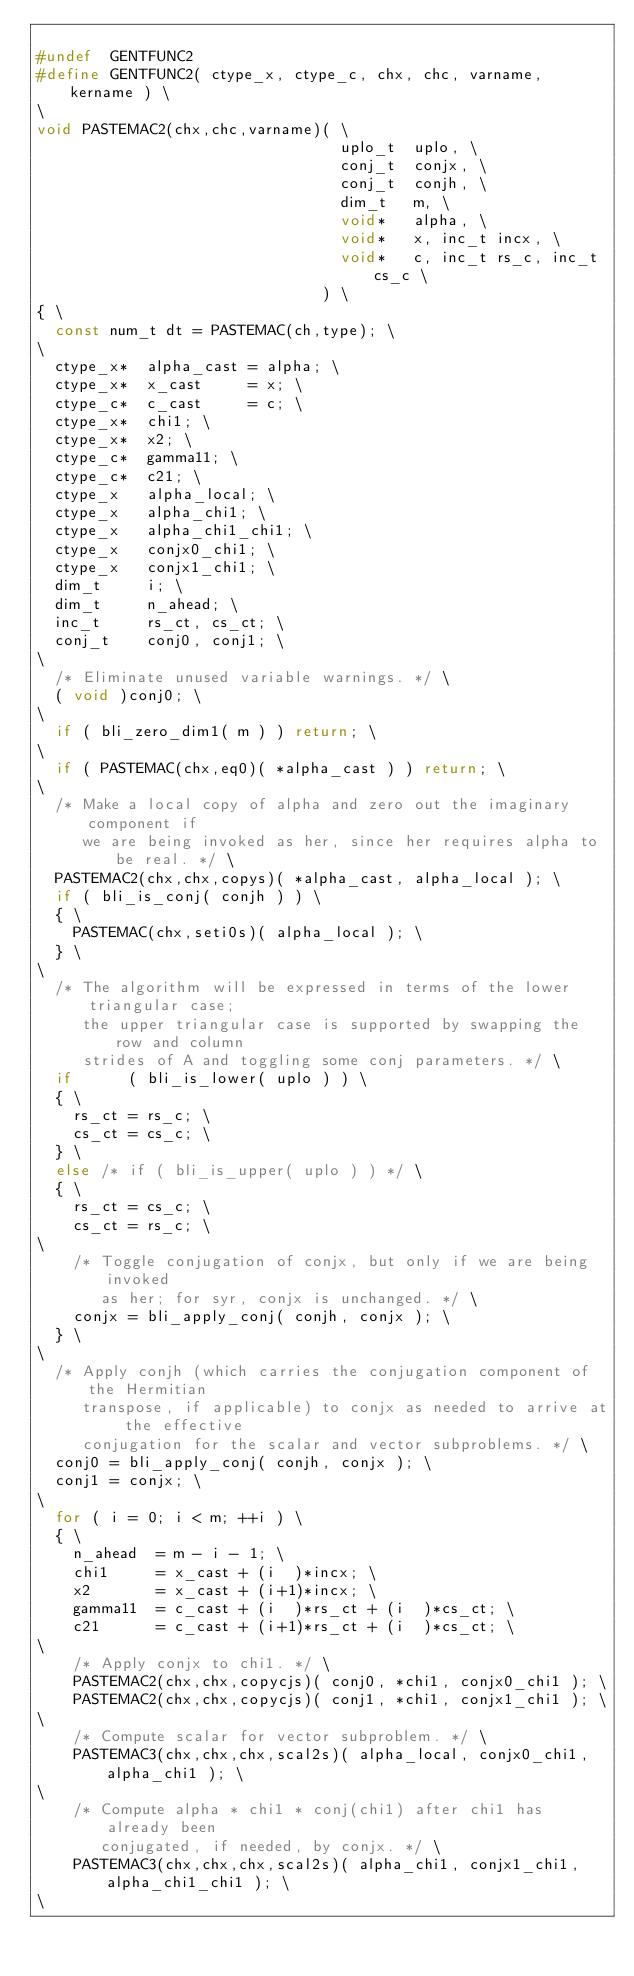Convert code to text. <code><loc_0><loc_0><loc_500><loc_500><_C_>
#undef  GENTFUNC2
#define GENTFUNC2( ctype_x, ctype_c, chx, chc, varname, kername ) \
\
void PASTEMAC2(chx,chc,varname)( \
                                 uplo_t  uplo, \
                                 conj_t  conjx, \
                                 conj_t  conjh, \
                                 dim_t   m, \
                                 void*   alpha, \
                                 void*   x, inc_t incx, \
                                 void*   c, inc_t rs_c, inc_t cs_c \
                               ) \
{ \
	const num_t dt = PASTEMAC(ch,type); \
\
	ctype_x*  alpha_cast = alpha; \
	ctype_x*  x_cast     = x; \
	ctype_c*  c_cast     = c; \
	ctype_x*  chi1; \
	ctype_x*  x2; \
	ctype_c*  gamma11; \
	ctype_c*  c21; \
	ctype_x   alpha_local; \
	ctype_x   alpha_chi1; \
	ctype_x   alpha_chi1_chi1; \
	ctype_x   conjx0_chi1; \
	ctype_x   conjx1_chi1; \
	dim_t     i; \
	dim_t     n_ahead; \
	inc_t     rs_ct, cs_ct; \
	conj_t    conj0, conj1; \
\
	/* Eliminate unused variable warnings. */ \
	( void )conj0; \
\
	if ( bli_zero_dim1( m ) ) return; \
\
	if ( PASTEMAC(chx,eq0)( *alpha_cast ) ) return; \
\
	/* Make a local copy of alpha and zero out the imaginary component if
	   we are being invoked as her, since her requires alpha to be real. */ \
	PASTEMAC2(chx,chx,copys)( *alpha_cast, alpha_local ); \
	if ( bli_is_conj( conjh ) ) \
	{ \
		PASTEMAC(chx,seti0s)( alpha_local ); \
	} \
\
	/* The algorithm will be expressed in terms of the lower triangular case;
	   the upper triangular case is supported by swapping the row and column
	   strides of A and toggling some conj parameters. */ \
	if      ( bli_is_lower( uplo ) ) \
	{ \
		rs_ct = rs_c; \
		cs_ct = cs_c; \
	} \
	else /* if ( bli_is_upper( uplo ) ) */ \
	{ \
		rs_ct = cs_c; \
		cs_ct = rs_c; \
\
		/* Toggle conjugation of conjx, but only if we are being invoked
		   as her; for syr, conjx is unchanged. */ \
		conjx = bli_apply_conj( conjh, conjx ); \
	} \
\
	/* Apply conjh (which carries the conjugation component of the Hermitian
	   transpose, if applicable) to conjx as needed to arrive at the effective
	   conjugation for the scalar and vector subproblems. */ \
	conj0 = bli_apply_conj( conjh, conjx ); \
	conj1 = conjx; \
\
	for ( i = 0; i < m; ++i ) \
	{ \
		n_ahead  = m - i - 1; \
		chi1     = x_cast + (i  )*incx; \
		x2       = x_cast + (i+1)*incx; \
		gamma11  = c_cast + (i  )*rs_ct + (i  )*cs_ct; \
		c21      = c_cast + (i+1)*rs_ct + (i  )*cs_ct; \
\
		/* Apply conjx to chi1. */ \
		PASTEMAC2(chx,chx,copycjs)( conj0, *chi1, conjx0_chi1 ); \
		PASTEMAC2(chx,chx,copycjs)( conj1, *chi1, conjx1_chi1 ); \
\
		/* Compute scalar for vector subproblem. */ \
		PASTEMAC3(chx,chx,chx,scal2s)( alpha_local, conjx0_chi1, alpha_chi1 ); \
\
		/* Compute alpha * chi1 * conj(chi1) after chi1 has already been
		   conjugated, if needed, by conjx. */ \
		PASTEMAC3(chx,chx,chx,scal2s)( alpha_chi1, conjx1_chi1, alpha_chi1_chi1 ); \
\</code> 